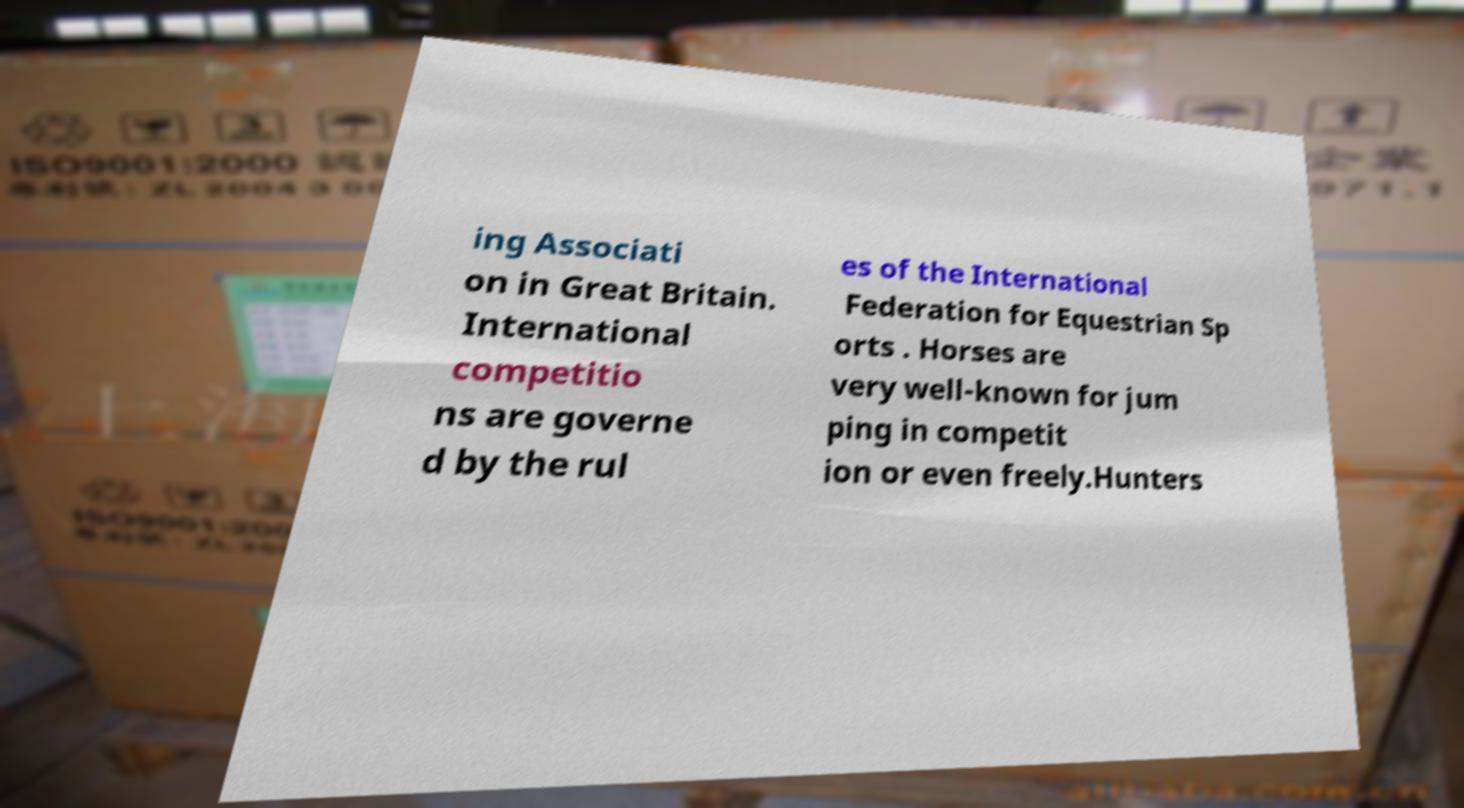I need the written content from this picture converted into text. Can you do that? ing Associati on in Great Britain. International competitio ns are governe d by the rul es of the International Federation for Equestrian Sp orts . Horses are very well-known for jum ping in competit ion or even freely.Hunters 